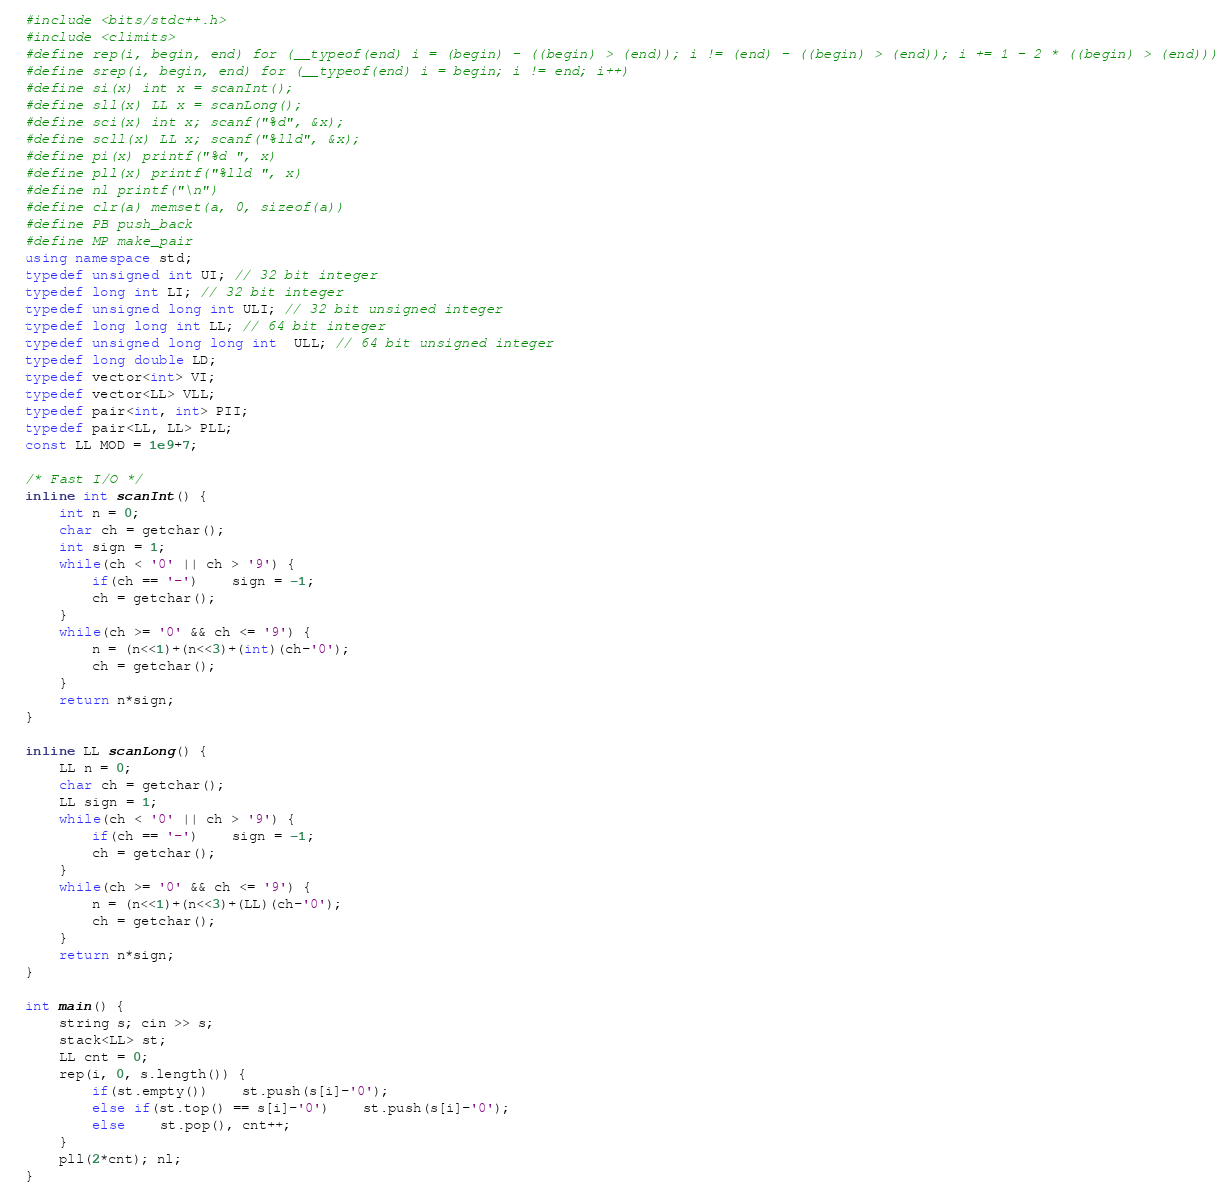Convert code to text. <code><loc_0><loc_0><loc_500><loc_500><_C++_>#include <bits/stdc++.h>
#include <climits>
#define rep(i, begin, end) for (__typeof(end) i = (begin) - ((begin) > (end)); i != (end) - ((begin) > (end)); i += 1 - 2 * ((begin) > (end)))
#define srep(i, begin, end) for (__typeof(end) i = begin; i != end; i++)
#define si(x) int x = scanInt();
#define sll(x) LL x = scanLong();
#define sci(x) int x; scanf("%d", &x);
#define scll(x) LL x; scanf("%lld", &x);
#define pi(x) printf("%d ", x)
#define pll(x) printf("%lld ", x)
#define nl printf("\n")
#define clr(a) memset(a, 0, sizeof(a))
#define PB push_back
#define MP make_pair
using namespace std;
typedef unsigned int UI; // 32 bit integer
typedef long int LI; // 32 bit integer
typedef unsigned long int ULI; // 32 bit unsigned integer
typedef long long int LL; // 64 bit integer
typedef unsigned long long int  ULL; // 64 bit unsigned integer
typedef long double LD;
typedef vector<int> VI;
typedef vector<LL> VLL;
typedef pair<int, int> PII;
typedef pair<LL, LL> PLL;
const LL MOD = 1e9+7;

/* Fast I/O */
inline int scanInt() {
	int n = 0;
	char ch = getchar();
	int sign = 1;
	while(ch < '0' || ch > '9') {
		if(ch == '-')	sign = -1;
		ch = getchar();
	}
	while(ch >= '0' && ch <= '9') {
		n = (n<<1)+(n<<3)+(int)(ch-'0');
		ch = getchar();
	}
	return n*sign;
}

inline LL scanLong() {
	LL n = 0;
	char ch = getchar();
	LL sign = 1;
	while(ch < '0' || ch > '9') {
		if(ch == '-')	sign = -1;
		ch = getchar();
	}
	while(ch >= '0' && ch <= '9') {
		n = (n<<1)+(n<<3)+(LL)(ch-'0');
		ch = getchar();
	}
	return n*sign;
}

int main() {
	string s; cin >> s;
	stack<LL> st;
	LL cnt = 0;
	rep(i, 0, s.length()) {
		if(st.empty())	st.push(s[i]-'0');
		else if(st.top() == s[i]-'0')	st.push(s[i]-'0');
		else	st.pop(), cnt++;
	}
	pll(2*cnt); nl;
}
</code> 